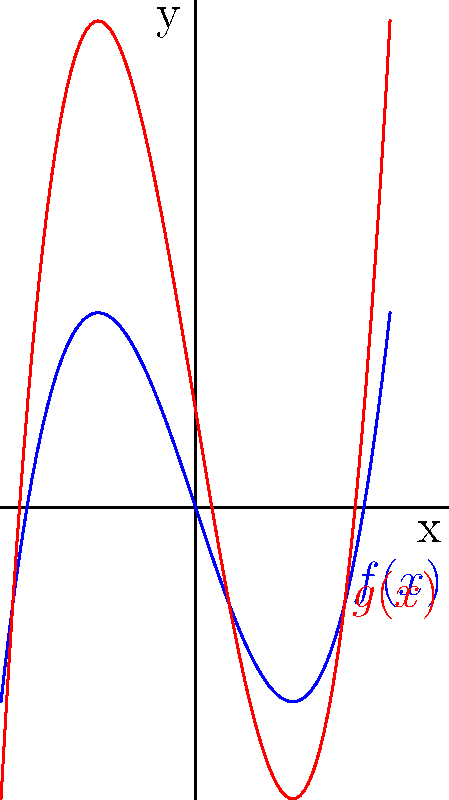As a successful entrepreneur who values precision and efficiency, analyze the graph above. The blue curve represents $f(x) = x^3 - 3x$, and the red curve represents $g(x)$. Determine the transformation applied to $f(x)$ to obtain $g(x)$. How would this transformation affect your business strategy if these curves represented market trends? To determine the transformation from $f(x)$ to $g(x)$, let's analyze the changes step-by-step:

1) First, observe that the overall shape of both curves is similar, indicating that the basic polynomial structure is preserved.

2) The red curve ($g(x)$) appears to be vertically stretched compared to the blue curve ($f(x)$). This suggests a vertical scaling factor.

3) The red curve is also shifted upward relative to the blue curve, indicating a vertical translation.

4) To quantify these transformations:
   a) The vertical stretch can be determined by comparing the amplitude of the curves. The red curve appears to be twice as tall as the blue curve, suggesting a scaling factor of 2.
   b) After accounting for the stretch, there's still an upward shift of 1 unit.

5) Therefore, the transformation from $f(x)$ to $g(x)$ can be expressed as:
   $g(x) = 2f(x) + 1$

6) Substituting $f(x) = x^3 - 3x$, we get:
   $g(x) = 2(x^3 - 3x) + 1$

In a business context, this transformation would represent:
- Doubling the magnitude of market trends (vertical stretch by 2)
- Adding a constant positive factor (upward shift by 1)

This could indicate a strategy of amplifying market movements while maintaining a consistent baseline advantage.
Answer: $g(x) = 2f(x) + 1$ 